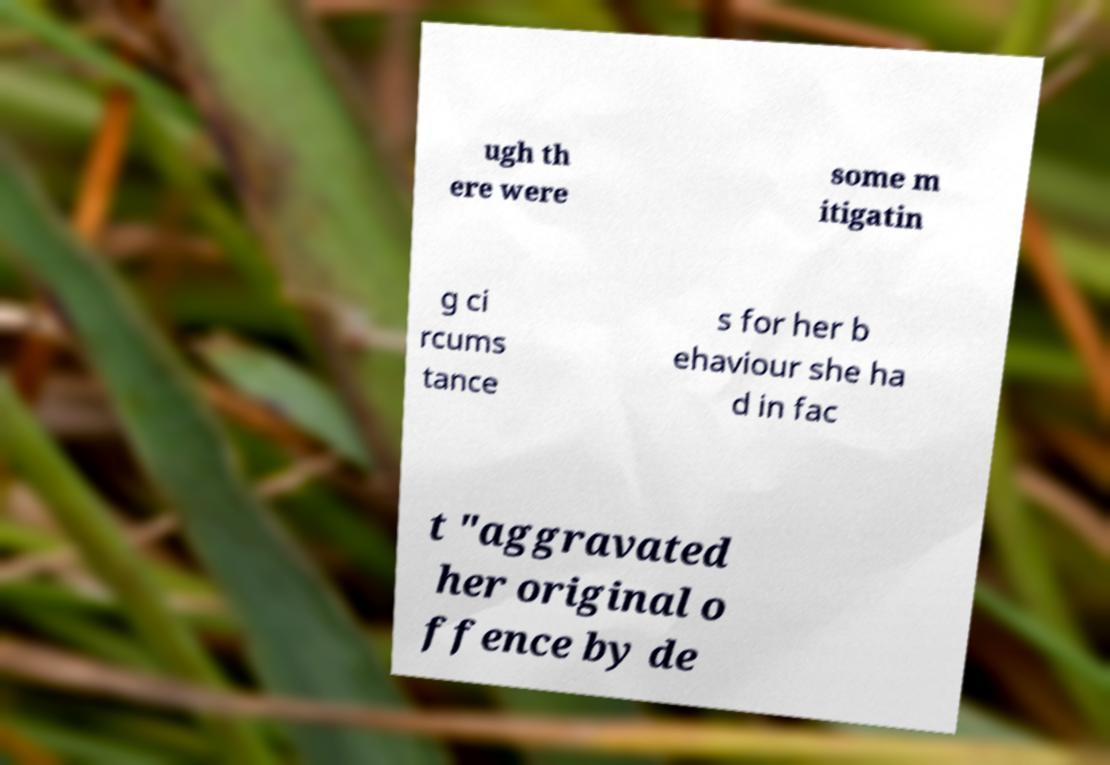Could you extract and type out the text from this image? ugh th ere were some m itigatin g ci rcums tance s for her b ehaviour she ha d in fac t "aggravated her original o ffence by de 